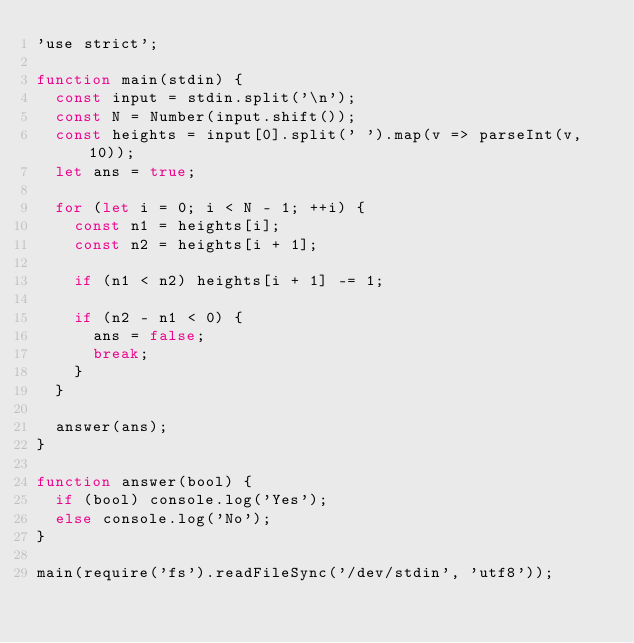Convert code to text. <code><loc_0><loc_0><loc_500><loc_500><_JavaScript_>'use strict';

function main(stdin) {
  const input = stdin.split('\n');
  const N = Number(input.shift());
  const heights = input[0].split(' ').map(v => parseInt(v, 10));
  let ans = true;

  for (let i = 0; i < N - 1; ++i) {
    const n1 = heights[i];
    const n2 = heights[i + 1];

    if (n1 < n2) heights[i + 1] -= 1;

    if (n2 - n1 < 0) {
      ans = false;
      break;
    }
  }

  answer(ans);
}

function answer(bool) {
  if (bool) console.log('Yes');
  else console.log('No');
}

main(require('fs').readFileSync('/dev/stdin', 'utf8'));</code> 